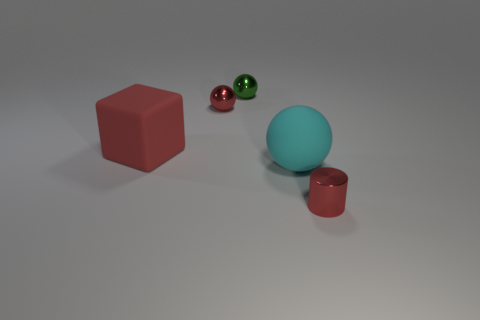Are there any tiny spheres?
Give a very brief answer. Yes. There is a large rubber thing that is to the left of the cyan ball; are there any red metal balls on the left side of it?
Provide a short and direct response. No. There is another small object that is the same shape as the green metal thing; what is it made of?
Offer a very short reply. Metal. Are there more large purple things than green metal objects?
Provide a short and direct response. No. Is the color of the rubber block the same as the small shiny thing that is in front of the cyan matte object?
Provide a short and direct response. Yes. The object that is on the left side of the cyan rubber object and in front of the red sphere is what color?
Keep it short and to the point. Red. What number of other objects are there of the same material as the tiny green thing?
Give a very brief answer. 2. Are there fewer metallic things than objects?
Keep it short and to the point. Yes. Are the tiny green sphere and the big object behind the big cyan rubber thing made of the same material?
Give a very brief answer. No. What shape is the red thing in front of the large cyan rubber sphere?
Make the answer very short. Cylinder. 